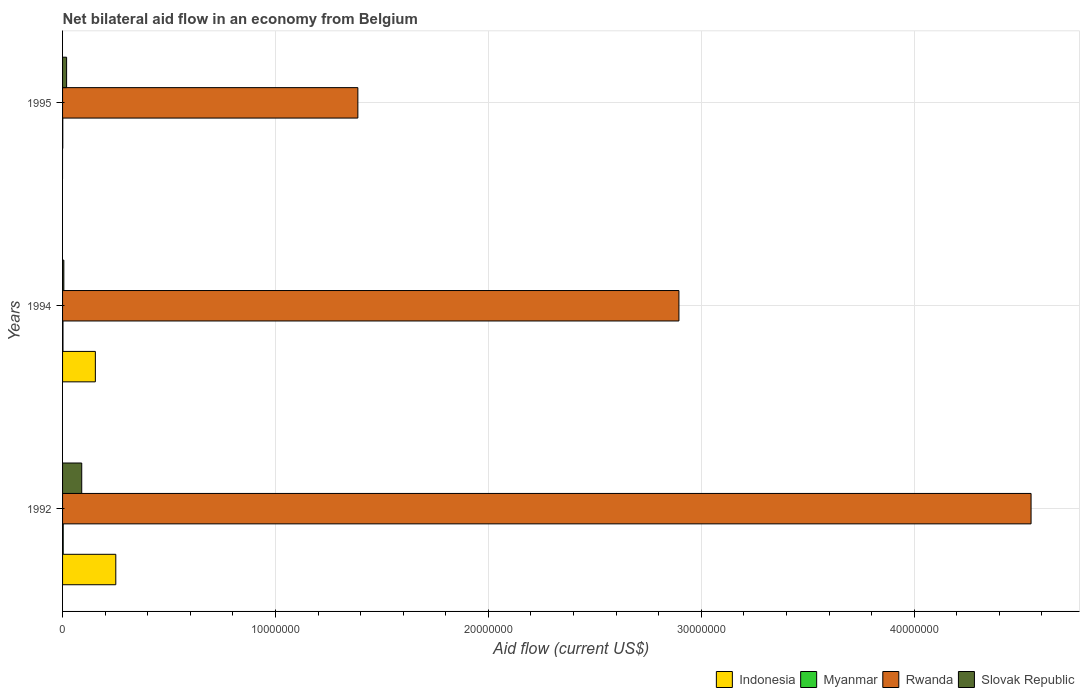Are the number of bars on each tick of the Y-axis equal?
Provide a succinct answer. No. How many bars are there on the 3rd tick from the top?
Your answer should be very brief. 4. How many bars are there on the 2nd tick from the bottom?
Offer a terse response. 4. What is the label of the 3rd group of bars from the top?
Give a very brief answer. 1992. What is the net bilateral aid flow in Myanmar in 1994?
Offer a very short reply. 2.00e+04. Across all years, what is the maximum net bilateral aid flow in Indonesia?
Your answer should be very brief. 2.50e+06. Across all years, what is the minimum net bilateral aid flow in Rwanda?
Keep it short and to the point. 1.39e+07. What is the total net bilateral aid flow in Indonesia in the graph?
Provide a succinct answer. 4.04e+06. What is the difference between the net bilateral aid flow in Slovak Republic in 1992 and that in 1995?
Provide a short and direct response. 7.10e+05. What is the difference between the net bilateral aid flow in Myanmar in 1994 and the net bilateral aid flow in Slovak Republic in 1992?
Your answer should be very brief. -8.80e+05. What is the average net bilateral aid flow in Slovak Republic per year?
Provide a short and direct response. 3.83e+05. In the year 1994, what is the difference between the net bilateral aid flow in Slovak Republic and net bilateral aid flow in Myanmar?
Your response must be concise. 4.00e+04. What is the ratio of the net bilateral aid flow in Rwanda in 1992 to that in 1994?
Offer a terse response. 1.57. What is the difference between the highest and the lowest net bilateral aid flow in Slovak Republic?
Your answer should be very brief. 8.40e+05. Is the sum of the net bilateral aid flow in Indonesia in 1992 and 1994 greater than the maximum net bilateral aid flow in Myanmar across all years?
Give a very brief answer. Yes. Is it the case that in every year, the sum of the net bilateral aid flow in Myanmar and net bilateral aid flow in Rwanda is greater than the net bilateral aid flow in Indonesia?
Give a very brief answer. Yes. How many bars are there?
Provide a short and direct response. 11. Are all the bars in the graph horizontal?
Your answer should be very brief. Yes. What is the difference between two consecutive major ticks on the X-axis?
Keep it short and to the point. 1.00e+07. Where does the legend appear in the graph?
Your answer should be very brief. Bottom right. What is the title of the graph?
Offer a terse response. Net bilateral aid flow in an economy from Belgium. What is the Aid flow (current US$) in Indonesia in 1992?
Keep it short and to the point. 2.50e+06. What is the Aid flow (current US$) in Rwanda in 1992?
Your answer should be compact. 4.55e+07. What is the Aid flow (current US$) of Indonesia in 1994?
Ensure brevity in your answer.  1.54e+06. What is the Aid flow (current US$) in Rwanda in 1994?
Offer a terse response. 2.90e+07. What is the Aid flow (current US$) in Indonesia in 1995?
Offer a terse response. 0. What is the Aid flow (current US$) in Myanmar in 1995?
Keep it short and to the point. 10000. What is the Aid flow (current US$) in Rwanda in 1995?
Your answer should be compact. 1.39e+07. What is the Aid flow (current US$) in Slovak Republic in 1995?
Keep it short and to the point. 1.90e+05. Across all years, what is the maximum Aid flow (current US$) in Indonesia?
Keep it short and to the point. 2.50e+06. Across all years, what is the maximum Aid flow (current US$) of Rwanda?
Make the answer very short. 4.55e+07. Across all years, what is the minimum Aid flow (current US$) of Indonesia?
Make the answer very short. 0. Across all years, what is the minimum Aid flow (current US$) of Rwanda?
Offer a terse response. 1.39e+07. Across all years, what is the minimum Aid flow (current US$) in Slovak Republic?
Provide a short and direct response. 6.00e+04. What is the total Aid flow (current US$) in Indonesia in the graph?
Provide a short and direct response. 4.04e+06. What is the total Aid flow (current US$) of Myanmar in the graph?
Offer a very short reply. 6.00e+04. What is the total Aid flow (current US$) of Rwanda in the graph?
Keep it short and to the point. 8.83e+07. What is the total Aid flow (current US$) of Slovak Republic in the graph?
Ensure brevity in your answer.  1.15e+06. What is the difference between the Aid flow (current US$) of Indonesia in 1992 and that in 1994?
Your response must be concise. 9.60e+05. What is the difference between the Aid flow (current US$) in Rwanda in 1992 and that in 1994?
Your response must be concise. 1.65e+07. What is the difference between the Aid flow (current US$) in Slovak Republic in 1992 and that in 1994?
Your response must be concise. 8.40e+05. What is the difference between the Aid flow (current US$) in Rwanda in 1992 and that in 1995?
Your answer should be compact. 3.16e+07. What is the difference between the Aid flow (current US$) of Slovak Republic in 1992 and that in 1995?
Give a very brief answer. 7.10e+05. What is the difference between the Aid flow (current US$) in Myanmar in 1994 and that in 1995?
Your answer should be very brief. 10000. What is the difference between the Aid flow (current US$) in Rwanda in 1994 and that in 1995?
Give a very brief answer. 1.51e+07. What is the difference between the Aid flow (current US$) in Indonesia in 1992 and the Aid flow (current US$) in Myanmar in 1994?
Give a very brief answer. 2.48e+06. What is the difference between the Aid flow (current US$) of Indonesia in 1992 and the Aid flow (current US$) of Rwanda in 1994?
Your answer should be compact. -2.64e+07. What is the difference between the Aid flow (current US$) of Indonesia in 1992 and the Aid flow (current US$) of Slovak Republic in 1994?
Ensure brevity in your answer.  2.44e+06. What is the difference between the Aid flow (current US$) of Myanmar in 1992 and the Aid flow (current US$) of Rwanda in 1994?
Your answer should be very brief. -2.89e+07. What is the difference between the Aid flow (current US$) of Myanmar in 1992 and the Aid flow (current US$) of Slovak Republic in 1994?
Provide a short and direct response. -3.00e+04. What is the difference between the Aid flow (current US$) of Rwanda in 1992 and the Aid flow (current US$) of Slovak Republic in 1994?
Offer a very short reply. 4.54e+07. What is the difference between the Aid flow (current US$) in Indonesia in 1992 and the Aid flow (current US$) in Myanmar in 1995?
Give a very brief answer. 2.49e+06. What is the difference between the Aid flow (current US$) in Indonesia in 1992 and the Aid flow (current US$) in Rwanda in 1995?
Your answer should be very brief. -1.14e+07. What is the difference between the Aid flow (current US$) in Indonesia in 1992 and the Aid flow (current US$) in Slovak Republic in 1995?
Your response must be concise. 2.31e+06. What is the difference between the Aid flow (current US$) of Myanmar in 1992 and the Aid flow (current US$) of Rwanda in 1995?
Provide a short and direct response. -1.38e+07. What is the difference between the Aid flow (current US$) in Myanmar in 1992 and the Aid flow (current US$) in Slovak Republic in 1995?
Your response must be concise. -1.60e+05. What is the difference between the Aid flow (current US$) of Rwanda in 1992 and the Aid flow (current US$) of Slovak Republic in 1995?
Offer a terse response. 4.53e+07. What is the difference between the Aid flow (current US$) in Indonesia in 1994 and the Aid flow (current US$) in Myanmar in 1995?
Your answer should be very brief. 1.53e+06. What is the difference between the Aid flow (current US$) in Indonesia in 1994 and the Aid flow (current US$) in Rwanda in 1995?
Offer a terse response. -1.23e+07. What is the difference between the Aid flow (current US$) in Indonesia in 1994 and the Aid flow (current US$) in Slovak Republic in 1995?
Your response must be concise. 1.35e+06. What is the difference between the Aid flow (current US$) of Myanmar in 1994 and the Aid flow (current US$) of Rwanda in 1995?
Your response must be concise. -1.38e+07. What is the difference between the Aid flow (current US$) of Myanmar in 1994 and the Aid flow (current US$) of Slovak Republic in 1995?
Keep it short and to the point. -1.70e+05. What is the difference between the Aid flow (current US$) of Rwanda in 1994 and the Aid flow (current US$) of Slovak Republic in 1995?
Keep it short and to the point. 2.88e+07. What is the average Aid flow (current US$) in Indonesia per year?
Provide a short and direct response. 1.35e+06. What is the average Aid flow (current US$) in Rwanda per year?
Ensure brevity in your answer.  2.94e+07. What is the average Aid flow (current US$) of Slovak Republic per year?
Your response must be concise. 3.83e+05. In the year 1992, what is the difference between the Aid flow (current US$) of Indonesia and Aid flow (current US$) of Myanmar?
Your answer should be very brief. 2.47e+06. In the year 1992, what is the difference between the Aid flow (current US$) in Indonesia and Aid flow (current US$) in Rwanda?
Offer a terse response. -4.30e+07. In the year 1992, what is the difference between the Aid flow (current US$) of Indonesia and Aid flow (current US$) of Slovak Republic?
Ensure brevity in your answer.  1.60e+06. In the year 1992, what is the difference between the Aid flow (current US$) of Myanmar and Aid flow (current US$) of Rwanda?
Provide a succinct answer. -4.55e+07. In the year 1992, what is the difference between the Aid flow (current US$) in Myanmar and Aid flow (current US$) in Slovak Republic?
Keep it short and to the point. -8.70e+05. In the year 1992, what is the difference between the Aid flow (current US$) of Rwanda and Aid flow (current US$) of Slovak Republic?
Give a very brief answer. 4.46e+07. In the year 1994, what is the difference between the Aid flow (current US$) in Indonesia and Aid flow (current US$) in Myanmar?
Give a very brief answer. 1.52e+06. In the year 1994, what is the difference between the Aid flow (current US$) of Indonesia and Aid flow (current US$) of Rwanda?
Your answer should be very brief. -2.74e+07. In the year 1994, what is the difference between the Aid flow (current US$) of Indonesia and Aid flow (current US$) of Slovak Republic?
Offer a very short reply. 1.48e+06. In the year 1994, what is the difference between the Aid flow (current US$) in Myanmar and Aid flow (current US$) in Rwanda?
Your answer should be very brief. -2.89e+07. In the year 1994, what is the difference between the Aid flow (current US$) of Myanmar and Aid flow (current US$) of Slovak Republic?
Keep it short and to the point. -4.00e+04. In the year 1994, what is the difference between the Aid flow (current US$) of Rwanda and Aid flow (current US$) of Slovak Republic?
Ensure brevity in your answer.  2.89e+07. In the year 1995, what is the difference between the Aid flow (current US$) in Myanmar and Aid flow (current US$) in Rwanda?
Your answer should be compact. -1.39e+07. In the year 1995, what is the difference between the Aid flow (current US$) of Myanmar and Aid flow (current US$) of Slovak Republic?
Make the answer very short. -1.80e+05. In the year 1995, what is the difference between the Aid flow (current US$) in Rwanda and Aid flow (current US$) in Slovak Republic?
Give a very brief answer. 1.37e+07. What is the ratio of the Aid flow (current US$) of Indonesia in 1992 to that in 1994?
Your answer should be compact. 1.62. What is the ratio of the Aid flow (current US$) of Myanmar in 1992 to that in 1994?
Keep it short and to the point. 1.5. What is the ratio of the Aid flow (current US$) in Rwanda in 1992 to that in 1994?
Make the answer very short. 1.57. What is the ratio of the Aid flow (current US$) in Rwanda in 1992 to that in 1995?
Your answer should be very brief. 3.28. What is the ratio of the Aid flow (current US$) in Slovak Republic in 1992 to that in 1995?
Ensure brevity in your answer.  4.74. What is the ratio of the Aid flow (current US$) in Rwanda in 1994 to that in 1995?
Your answer should be compact. 2.09. What is the ratio of the Aid flow (current US$) of Slovak Republic in 1994 to that in 1995?
Ensure brevity in your answer.  0.32. What is the difference between the highest and the second highest Aid flow (current US$) of Rwanda?
Keep it short and to the point. 1.65e+07. What is the difference between the highest and the second highest Aid flow (current US$) of Slovak Republic?
Offer a very short reply. 7.10e+05. What is the difference between the highest and the lowest Aid flow (current US$) in Indonesia?
Your response must be concise. 2.50e+06. What is the difference between the highest and the lowest Aid flow (current US$) in Myanmar?
Give a very brief answer. 2.00e+04. What is the difference between the highest and the lowest Aid flow (current US$) of Rwanda?
Provide a succinct answer. 3.16e+07. What is the difference between the highest and the lowest Aid flow (current US$) of Slovak Republic?
Offer a terse response. 8.40e+05. 